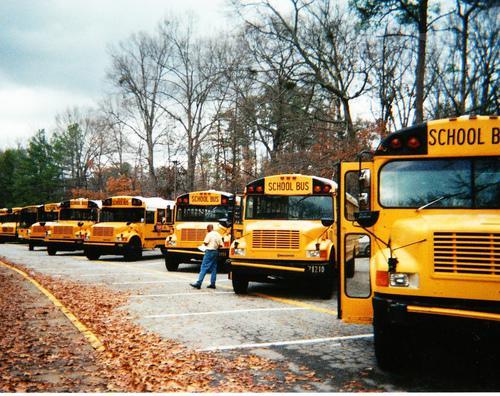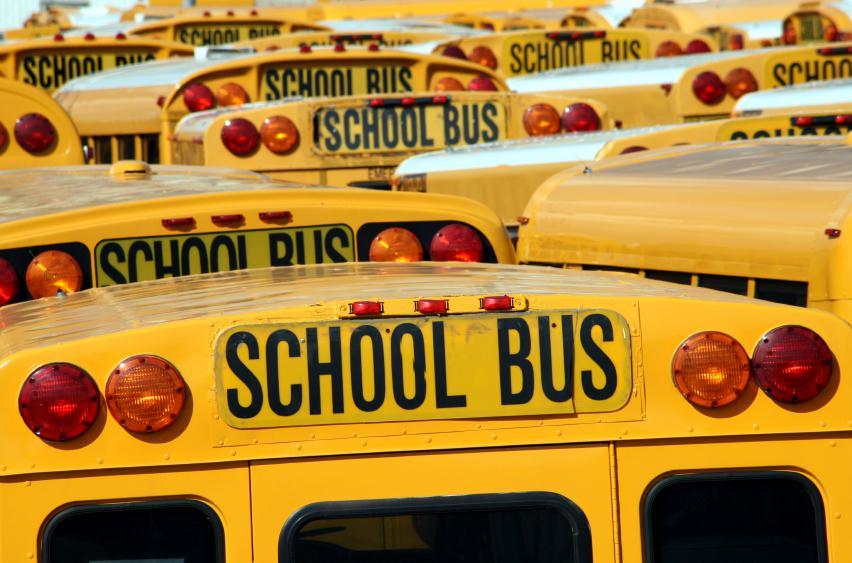The first image is the image on the left, the second image is the image on the right. Assess this claim about the two images: "One of the busses has graffiti on it.". Correct or not? Answer yes or no. No. The first image is the image on the left, the second image is the image on the right. Evaluate the accuracy of this statement regarding the images: "The photo on the right shows a school bus that has been painted, while the image on the left shows a row of at least five school buses.". Is it true? Answer yes or no. No. 